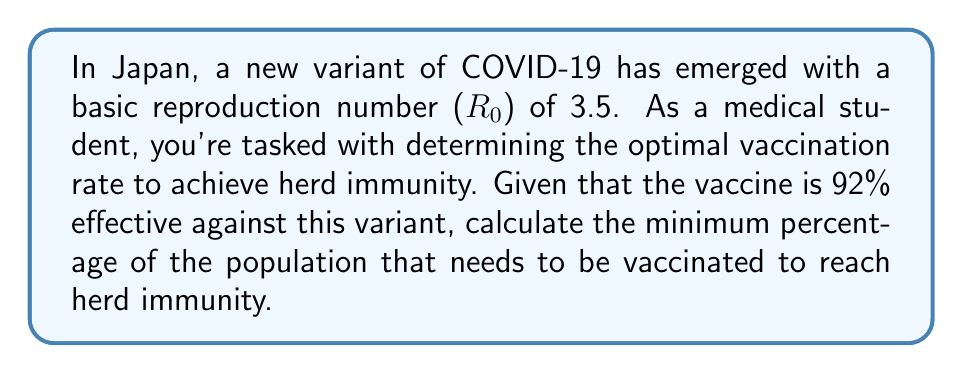Solve this math problem. To solve this problem, we'll use the concept of herd immunity threshold and vaccine effectiveness. The steps are as follows:

1. The herd immunity threshold (HIT) is given by the formula:

   $$HIT = 1 - \frac{1}{R_0}$$

   where $R_0$ is the basic reproduction number.

2. Substituting $R_0 = 3.5$ into the formula:

   $$HIT = 1 - \frac{1}{3.5} = 1 - 0.2857 = 0.7143$$

3. This means that 71.43% of the population needs to be immune to achieve herd immunity.

4. However, the vaccine is not 100% effective. We need to account for vaccine effectiveness (VE) which is 92% or 0.92.

5. To calculate the vaccination coverage (VC) needed, we use the formula:

   $$VC = \frac{HIT}{VE}$$

6. Substituting the values:

   $$VC = \frac{0.7143}{0.92} = 0.7764$$

7. Convert to percentage:

   $$0.7764 \times 100\% = 77.64\%$$

Therefore, approximately 77.64% of the population needs to be vaccinated to achieve herd immunity.
Answer: 77.64% 